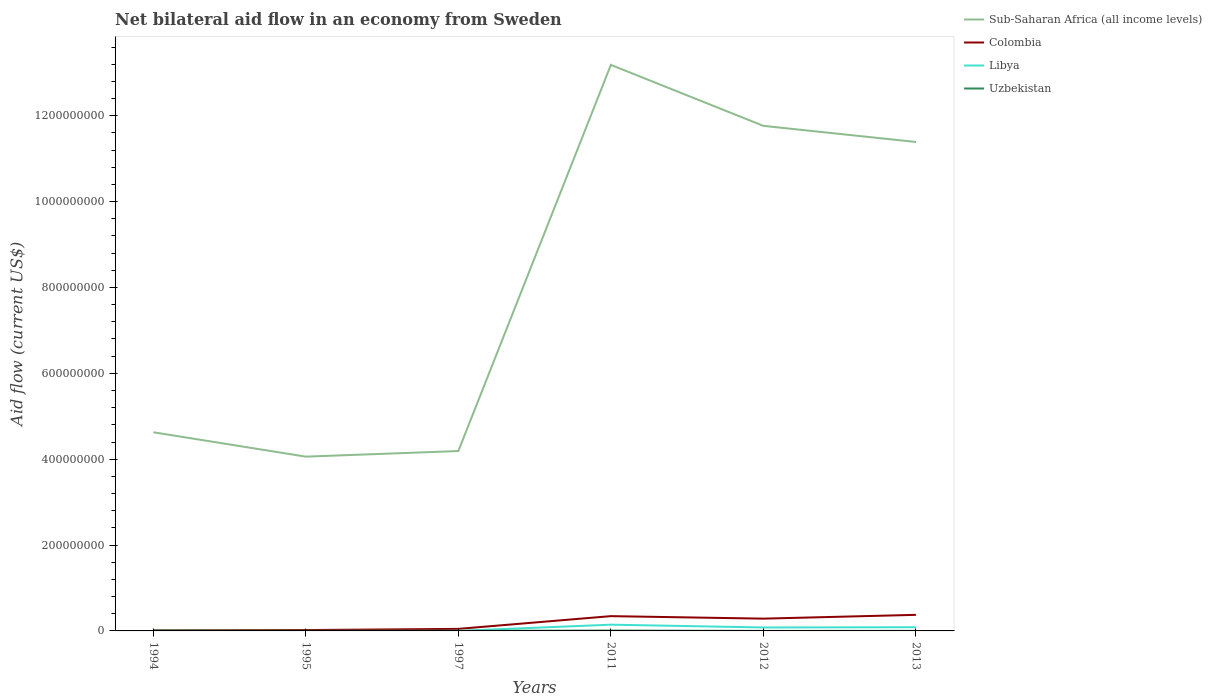Across all years, what is the maximum net bilateral aid flow in Sub-Saharan Africa (all income levels)?
Provide a succinct answer. 4.06e+08. In which year was the net bilateral aid flow in Libya maximum?
Provide a succinct answer. 1995. What is the total net bilateral aid flow in Uzbekistan in the graph?
Offer a very short reply. 8.10e+05. What is the difference between the highest and the second highest net bilateral aid flow in Colombia?
Keep it short and to the point. 3.62e+07. What is the difference between the highest and the lowest net bilateral aid flow in Uzbekistan?
Offer a terse response. 2. How many lines are there?
Your answer should be very brief. 4. What is the difference between two consecutive major ticks on the Y-axis?
Keep it short and to the point. 2.00e+08. Are the values on the major ticks of Y-axis written in scientific E-notation?
Ensure brevity in your answer.  No. Does the graph contain grids?
Give a very brief answer. No. Where does the legend appear in the graph?
Offer a terse response. Top right. How are the legend labels stacked?
Your answer should be very brief. Vertical. What is the title of the graph?
Provide a succinct answer. Net bilateral aid flow in an economy from Sweden. Does "Austria" appear as one of the legend labels in the graph?
Provide a succinct answer. No. What is the label or title of the X-axis?
Your response must be concise. Years. What is the Aid flow (current US$) in Sub-Saharan Africa (all income levels) in 1994?
Give a very brief answer. 4.63e+08. What is the Aid flow (current US$) in Colombia in 1994?
Ensure brevity in your answer.  1.24e+06. What is the Aid flow (current US$) of Libya in 1994?
Keep it short and to the point. 2.00e+04. What is the Aid flow (current US$) in Uzbekistan in 1994?
Offer a terse response. 8.60e+05. What is the Aid flow (current US$) in Sub-Saharan Africa (all income levels) in 1995?
Offer a very short reply. 4.06e+08. What is the Aid flow (current US$) in Colombia in 1995?
Offer a terse response. 2.02e+06. What is the Aid flow (current US$) in Libya in 1995?
Your answer should be compact. 10000. What is the Aid flow (current US$) of Sub-Saharan Africa (all income levels) in 1997?
Offer a very short reply. 4.19e+08. What is the Aid flow (current US$) of Colombia in 1997?
Your answer should be very brief. 4.76e+06. What is the Aid flow (current US$) in Sub-Saharan Africa (all income levels) in 2011?
Ensure brevity in your answer.  1.32e+09. What is the Aid flow (current US$) in Colombia in 2011?
Ensure brevity in your answer.  3.44e+07. What is the Aid flow (current US$) of Libya in 2011?
Ensure brevity in your answer.  1.46e+07. What is the Aid flow (current US$) of Uzbekistan in 2011?
Make the answer very short. 8.30e+05. What is the Aid flow (current US$) of Sub-Saharan Africa (all income levels) in 2012?
Offer a very short reply. 1.18e+09. What is the Aid flow (current US$) of Colombia in 2012?
Ensure brevity in your answer.  2.86e+07. What is the Aid flow (current US$) of Libya in 2012?
Your response must be concise. 8.03e+06. What is the Aid flow (current US$) in Uzbekistan in 2012?
Your answer should be very brief. 5.00e+04. What is the Aid flow (current US$) of Sub-Saharan Africa (all income levels) in 2013?
Ensure brevity in your answer.  1.14e+09. What is the Aid flow (current US$) of Colombia in 2013?
Provide a short and direct response. 3.74e+07. What is the Aid flow (current US$) of Libya in 2013?
Provide a succinct answer. 8.59e+06. Across all years, what is the maximum Aid flow (current US$) of Sub-Saharan Africa (all income levels)?
Your answer should be very brief. 1.32e+09. Across all years, what is the maximum Aid flow (current US$) of Colombia?
Provide a short and direct response. 3.74e+07. Across all years, what is the maximum Aid flow (current US$) of Libya?
Ensure brevity in your answer.  1.46e+07. Across all years, what is the maximum Aid flow (current US$) in Uzbekistan?
Provide a succinct answer. 8.60e+05. Across all years, what is the minimum Aid flow (current US$) of Sub-Saharan Africa (all income levels)?
Provide a short and direct response. 4.06e+08. Across all years, what is the minimum Aid flow (current US$) in Colombia?
Make the answer very short. 1.24e+06. What is the total Aid flow (current US$) of Sub-Saharan Africa (all income levels) in the graph?
Offer a terse response. 4.92e+09. What is the total Aid flow (current US$) in Colombia in the graph?
Your answer should be compact. 1.09e+08. What is the total Aid flow (current US$) of Libya in the graph?
Make the answer very short. 3.13e+07. What is the total Aid flow (current US$) in Uzbekistan in the graph?
Your response must be concise. 2.07e+06. What is the difference between the Aid flow (current US$) in Sub-Saharan Africa (all income levels) in 1994 and that in 1995?
Your answer should be compact. 5.68e+07. What is the difference between the Aid flow (current US$) of Colombia in 1994 and that in 1995?
Keep it short and to the point. -7.80e+05. What is the difference between the Aid flow (current US$) in Uzbekistan in 1994 and that in 1995?
Offer a very short reply. 7.20e+05. What is the difference between the Aid flow (current US$) of Sub-Saharan Africa (all income levels) in 1994 and that in 1997?
Your answer should be very brief. 4.37e+07. What is the difference between the Aid flow (current US$) in Colombia in 1994 and that in 1997?
Your response must be concise. -3.52e+06. What is the difference between the Aid flow (current US$) in Uzbekistan in 1994 and that in 1997?
Give a very brief answer. 7.30e+05. What is the difference between the Aid flow (current US$) of Sub-Saharan Africa (all income levels) in 1994 and that in 2011?
Keep it short and to the point. -8.56e+08. What is the difference between the Aid flow (current US$) in Colombia in 1994 and that in 2011?
Your answer should be very brief. -3.32e+07. What is the difference between the Aid flow (current US$) in Libya in 1994 and that in 2011?
Your response must be concise. -1.45e+07. What is the difference between the Aid flow (current US$) in Sub-Saharan Africa (all income levels) in 1994 and that in 2012?
Give a very brief answer. -7.14e+08. What is the difference between the Aid flow (current US$) in Colombia in 1994 and that in 2012?
Your response must be concise. -2.74e+07. What is the difference between the Aid flow (current US$) of Libya in 1994 and that in 2012?
Your response must be concise. -8.01e+06. What is the difference between the Aid flow (current US$) of Uzbekistan in 1994 and that in 2012?
Give a very brief answer. 8.10e+05. What is the difference between the Aid flow (current US$) in Sub-Saharan Africa (all income levels) in 1994 and that in 2013?
Your response must be concise. -6.76e+08. What is the difference between the Aid flow (current US$) of Colombia in 1994 and that in 2013?
Keep it short and to the point. -3.62e+07. What is the difference between the Aid flow (current US$) in Libya in 1994 and that in 2013?
Make the answer very short. -8.57e+06. What is the difference between the Aid flow (current US$) in Sub-Saharan Africa (all income levels) in 1995 and that in 1997?
Make the answer very short. -1.30e+07. What is the difference between the Aid flow (current US$) in Colombia in 1995 and that in 1997?
Your response must be concise. -2.74e+06. What is the difference between the Aid flow (current US$) of Sub-Saharan Africa (all income levels) in 1995 and that in 2011?
Your answer should be compact. -9.13e+08. What is the difference between the Aid flow (current US$) in Colombia in 1995 and that in 2011?
Keep it short and to the point. -3.24e+07. What is the difference between the Aid flow (current US$) of Libya in 1995 and that in 2011?
Make the answer very short. -1.46e+07. What is the difference between the Aid flow (current US$) of Uzbekistan in 1995 and that in 2011?
Keep it short and to the point. -6.90e+05. What is the difference between the Aid flow (current US$) of Sub-Saharan Africa (all income levels) in 1995 and that in 2012?
Provide a short and direct response. -7.70e+08. What is the difference between the Aid flow (current US$) in Colombia in 1995 and that in 2012?
Your answer should be very brief. -2.66e+07. What is the difference between the Aid flow (current US$) of Libya in 1995 and that in 2012?
Your answer should be compact. -8.02e+06. What is the difference between the Aid flow (current US$) of Uzbekistan in 1995 and that in 2012?
Provide a succinct answer. 9.00e+04. What is the difference between the Aid flow (current US$) in Sub-Saharan Africa (all income levels) in 1995 and that in 2013?
Your answer should be compact. -7.33e+08. What is the difference between the Aid flow (current US$) in Colombia in 1995 and that in 2013?
Offer a terse response. -3.54e+07. What is the difference between the Aid flow (current US$) of Libya in 1995 and that in 2013?
Provide a short and direct response. -8.58e+06. What is the difference between the Aid flow (current US$) of Uzbekistan in 1995 and that in 2013?
Your answer should be very brief. 8.00e+04. What is the difference between the Aid flow (current US$) in Sub-Saharan Africa (all income levels) in 1997 and that in 2011?
Offer a terse response. -9.00e+08. What is the difference between the Aid flow (current US$) in Colombia in 1997 and that in 2011?
Provide a succinct answer. -2.97e+07. What is the difference between the Aid flow (current US$) of Libya in 1997 and that in 2011?
Your answer should be very brief. -1.45e+07. What is the difference between the Aid flow (current US$) of Uzbekistan in 1997 and that in 2011?
Make the answer very short. -7.00e+05. What is the difference between the Aid flow (current US$) in Sub-Saharan Africa (all income levels) in 1997 and that in 2012?
Ensure brevity in your answer.  -7.57e+08. What is the difference between the Aid flow (current US$) of Colombia in 1997 and that in 2012?
Provide a short and direct response. -2.38e+07. What is the difference between the Aid flow (current US$) in Libya in 1997 and that in 2012?
Offer a very short reply. -7.93e+06. What is the difference between the Aid flow (current US$) in Sub-Saharan Africa (all income levels) in 1997 and that in 2013?
Offer a terse response. -7.20e+08. What is the difference between the Aid flow (current US$) of Colombia in 1997 and that in 2013?
Your answer should be very brief. -3.27e+07. What is the difference between the Aid flow (current US$) in Libya in 1997 and that in 2013?
Your response must be concise. -8.49e+06. What is the difference between the Aid flow (current US$) in Sub-Saharan Africa (all income levels) in 2011 and that in 2012?
Your answer should be very brief. 1.42e+08. What is the difference between the Aid flow (current US$) in Colombia in 2011 and that in 2012?
Give a very brief answer. 5.83e+06. What is the difference between the Aid flow (current US$) in Libya in 2011 and that in 2012?
Offer a terse response. 6.53e+06. What is the difference between the Aid flow (current US$) of Uzbekistan in 2011 and that in 2012?
Your answer should be compact. 7.80e+05. What is the difference between the Aid flow (current US$) of Sub-Saharan Africa (all income levels) in 2011 and that in 2013?
Make the answer very short. 1.80e+08. What is the difference between the Aid flow (current US$) of Colombia in 2011 and that in 2013?
Provide a short and direct response. -3.01e+06. What is the difference between the Aid flow (current US$) in Libya in 2011 and that in 2013?
Your answer should be compact. 5.97e+06. What is the difference between the Aid flow (current US$) of Uzbekistan in 2011 and that in 2013?
Ensure brevity in your answer.  7.70e+05. What is the difference between the Aid flow (current US$) of Sub-Saharan Africa (all income levels) in 2012 and that in 2013?
Provide a short and direct response. 3.76e+07. What is the difference between the Aid flow (current US$) of Colombia in 2012 and that in 2013?
Keep it short and to the point. -8.84e+06. What is the difference between the Aid flow (current US$) of Libya in 2012 and that in 2013?
Provide a short and direct response. -5.60e+05. What is the difference between the Aid flow (current US$) in Sub-Saharan Africa (all income levels) in 1994 and the Aid flow (current US$) in Colombia in 1995?
Keep it short and to the point. 4.61e+08. What is the difference between the Aid flow (current US$) in Sub-Saharan Africa (all income levels) in 1994 and the Aid flow (current US$) in Libya in 1995?
Ensure brevity in your answer.  4.63e+08. What is the difference between the Aid flow (current US$) in Sub-Saharan Africa (all income levels) in 1994 and the Aid flow (current US$) in Uzbekistan in 1995?
Give a very brief answer. 4.63e+08. What is the difference between the Aid flow (current US$) in Colombia in 1994 and the Aid flow (current US$) in Libya in 1995?
Offer a terse response. 1.23e+06. What is the difference between the Aid flow (current US$) of Colombia in 1994 and the Aid flow (current US$) of Uzbekistan in 1995?
Make the answer very short. 1.10e+06. What is the difference between the Aid flow (current US$) of Libya in 1994 and the Aid flow (current US$) of Uzbekistan in 1995?
Your answer should be very brief. -1.20e+05. What is the difference between the Aid flow (current US$) in Sub-Saharan Africa (all income levels) in 1994 and the Aid flow (current US$) in Colombia in 1997?
Ensure brevity in your answer.  4.58e+08. What is the difference between the Aid flow (current US$) of Sub-Saharan Africa (all income levels) in 1994 and the Aid flow (current US$) of Libya in 1997?
Offer a very short reply. 4.63e+08. What is the difference between the Aid flow (current US$) of Sub-Saharan Africa (all income levels) in 1994 and the Aid flow (current US$) of Uzbekistan in 1997?
Your response must be concise. 4.63e+08. What is the difference between the Aid flow (current US$) of Colombia in 1994 and the Aid flow (current US$) of Libya in 1997?
Provide a succinct answer. 1.14e+06. What is the difference between the Aid flow (current US$) of Colombia in 1994 and the Aid flow (current US$) of Uzbekistan in 1997?
Give a very brief answer. 1.11e+06. What is the difference between the Aid flow (current US$) in Sub-Saharan Africa (all income levels) in 1994 and the Aid flow (current US$) in Colombia in 2011?
Offer a terse response. 4.28e+08. What is the difference between the Aid flow (current US$) in Sub-Saharan Africa (all income levels) in 1994 and the Aid flow (current US$) in Libya in 2011?
Give a very brief answer. 4.48e+08. What is the difference between the Aid flow (current US$) in Sub-Saharan Africa (all income levels) in 1994 and the Aid flow (current US$) in Uzbekistan in 2011?
Your response must be concise. 4.62e+08. What is the difference between the Aid flow (current US$) in Colombia in 1994 and the Aid flow (current US$) in Libya in 2011?
Provide a succinct answer. -1.33e+07. What is the difference between the Aid flow (current US$) in Libya in 1994 and the Aid flow (current US$) in Uzbekistan in 2011?
Ensure brevity in your answer.  -8.10e+05. What is the difference between the Aid flow (current US$) in Sub-Saharan Africa (all income levels) in 1994 and the Aid flow (current US$) in Colombia in 2012?
Provide a short and direct response. 4.34e+08. What is the difference between the Aid flow (current US$) in Sub-Saharan Africa (all income levels) in 1994 and the Aid flow (current US$) in Libya in 2012?
Your answer should be very brief. 4.55e+08. What is the difference between the Aid flow (current US$) of Sub-Saharan Africa (all income levels) in 1994 and the Aid flow (current US$) of Uzbekistan in 2012?
Make the answer very short. 4.63e+08. What is the difference between the Aid flow (current US$) of Colombia in 1994 and the Aid flow (current US$) of Libya in 2012?
Give a very brief answer. -6.79e+06. What is the difference between the Aid flow (current US$) in Colombia in 1994 and the Aid flow (current US$) in Uzbekistan in 2012?
Your answer should be very brief. 1.19e+06. What is the difference between the Aid flow (current US$) in Libya in 1994 and the Aid flow (current US$) in Uzbekistan in 2012?
Offer a very short reply. -3.00e+04. What is the difference between the Aid flow (current US$) in Sub-Saharan Africa (all income levels) in 1994 and the Aid flow (current US$) in Colombia in 2013?
Your response must be concise. 4.25e+08. What is the difference between the Aid flow (current US$) in Sub-Saharan Africa (all income levels) in 1994 and the Aid flow (current US$) in Libya in 2013?
Offer a terse response. 4.54e+08. What is the difference between the Aid flow (current US$) in Sub-Saharan Africa (all income levels) in 1994 and the Aid flow (current US$) in Uzbekistan in 2013?
Offer a very short reply. 4.63e+08. What is the difference between the Aid flow (current US$) in Colombia in 1994 and the Aid flow (current US$) in Libya in 2013?
Offer a very short reply. -7.35e+06. What is the difference between the Aid flow (current US$) of Colombia in 1994 and the Aid flow (current US$) of Uzbekistan in 2013?
Keep it short and to the point. 1.18e+06. What is the difference between the Aid flow (current US$) in Libya in 1994 and the Aid flow (current US$) in Uzbekistan in 2013?
Offer a terse response. -4.00e+04. What is the difference between the Aid flow (current US$) in Sub-Saharan Africa (all income levels) in 1995 and the Aid flow (current US$) in Colombia in 1997?
Offer a very short reply. 4.01e+08. What is the difference between the Aid flow (current US$) in Sub-Saharan Africa (all income levels) in 1995 and the Aid flow (current US$) in Libya in 1997?
Ensure brevity in your answer.  4.06e+08. What is the difference between the Aid flow (current US$) of Sub-Saharan Africa (all income levels) in 1995 and the Aid flow (current US$) of Uzbekistan in 1997?
Your answer should be very brief. 4.06e+08. What is the difference between the Aid flow (current US$) of Colombia in 1995 and the Aid flow (current US$) of Libya in 1997?
Your answer should be very brief. 1.92e+06. What is the difference between the Aid flow (current US$) in Colombia in 1995 and the Aid flow (current US$) in Uzbekistan in 1997?
Make the answer very short. 1.89e+06. What is the difference between the Aid flow (current US$) of Sub-Saharan Africa (all income levels) in 1995 and the Aid flow (current US$) of Colombia in 2011?
Your answer should be very brief. 3.72e+08. What is the difference between the Aid flow (current US$) in Sub-Saharan Africa (all income levels) in 1995 and the Aid flow (current US$) in Libya in 2011?
Make the answer very short. 3.91e+08. What is the difference between the Aid flow (current US$) in Sub-Saharan Africa (all income levels) in 1995 and the Aid flow (current US$) in Uzbekistan in 2011?
Make the answer very short. 4.05e+08. What is the difference between the Aid flow (current US$) of Colombia in 1995 and the Aid flow (current US$) of Libya in 2011?
Give a very brief answer. -1.25e+07. What is the difference between the Aid flow (current US$) in Colombia in 1995 and the Aid flow (current US$) in Uzbekistan in 2011?
Give a very brief answer. 1.19e+06. What is the difference between the Aid flow (current US$) of Libya in 1995 and the Aid flow (current US$) of Uzbekistan in 2011?
Your response must be concise. -8.20e+05. What is the difference between the Aid flow (current US$) of Sub-Saharan Africa (all income levels) in 1995 and the Aid flow (current US$) of Colombia in 2012?
Provide a short and direct response. 3.77e+08. What is the difference between the Aid flow (current US$) of Sub-Saharan Africa (all income levels) in 1995 and the Aid flow (current US$) of Libya in 2012?
Offer a very short reply. 3.98e+08. What is the difference between the Aid flow (current US$) in Sub-Saharan Africa (all income levels) in 1995 and the Aid flow (current US$) in Uzbekistan in 2012?
Provide a succinct answer. 4.06e+08. What is the difference between the Aid flow (current US$) in Colombia in 1995 and the Aid flow (current US$) in Libya in 2012?
Provide a short and direct response. -6.01e+06. What is the difference between the Aid flow (current US$) in Colombia in 1995 and the Aid flow (current US$) in Uzbekistan in 2012?
Offer a very short reply. 1.97e+06. What is the difference between the Aid flow (current US$) in Libya in 1995 and the Aid flow (current US$) in Uzbekistan in 2012?
Your answer should be compact. -4.00e+04. What is the difference between the Aid flow (current US$) of Sub-Saharan Africa (all income levels) in 1995 and the Aid flow (current US$) of Colombia in 2013?
Offer a terse response. 3.69e+08. What is the difference between the Aid flow (current US$) in Sub-Saharan Africa (all income levels) in 1995 and the Aid flow (current US$) in Libya in 2013?
Offer a very short reply. 3.97e+08. What is the difference between the Aid flow (current US$) in Sub-Saharan Africa (all income levels) in 1995 and the Aid flow (current US$) in Uzbekistan in 2013?
Make the answer very short. 4.06e+08. What is the difference between the Aid flow (current US$) in Colombia in 1995 and the Aid flow (current US$) in Libya in 2013?
Your response must be concise. -6.57e+06. What is the difference between the Aid flow (current US$) of Colombia in 1995 and the Aid flow (current US$) of Uzbekistan in 2013?
Keep it short and to the point. 1.96e+06. What is the difference between the Aid flow (current US$) in Libya in 1995 and the Aid flow (current US$) in Uzbekistan in 2013?
Keep it short and to the point. -5.00e+04. What is the difference between the Aid flow (current US$) in Sub-Saharan Africa (all income levels) in 1997 and the Aid flow (current US$) in Colombia in 2011?
Your response must be concise. 3.85e+08. What is the difference between the Aid flow (current US$) of Sub-Saharan Africa (all income levels) in 1997 and the Aid flow (current US$) of Libya in 2011?
Provide a short and direct response. 4.04e+08. What is the difference between the Aid flow (current US$) of Sub-Saharan Africa (all income levels) in 1997 and the Aid flow (current US$) of Uzbekistan in 2011?
Provide a short and direct response. 4.18e+08. What is the difference between the Aid flow (current US$) in Colombia in 1997 and the Aid flow (current US$) in Libya in 2011?
Offer a very short reply. -9.80e+06. What is the difference between the Aid flow (current US$) of Colombia in 1997 and the Aid flow (current US$) of Uzbekistan in 2011?
Ensure brevity in your answer.  3.93e+06. What is the difference between the Aid flow (current US$) of Libya in 1997 and the Aid flow (current US$) of Uzbekistan in 2011?
Your answer should be very brief. -7.30e+05. What is the difference between the Aid flow (current US$) of Sub-Saharan Africa (all income levels) in 1997 and the Aid flow (current US$) of Colombia in 2012?
Provide a short and direct response. 3.90e+08. What is the difference between the Aid flow (current US$) of Sub-Saharan Africa (all income levels) in 1997 and the Aid flow (current US$) of Libya in 2012?
Offer a terse response. 4.11e+08. What is the difference between the Aid flow (current US$) of Sub-Saharan Africa (all income levels) in 1997 and the Aid flow (current US$) of Uzbekistan in 2012?
Your response must be concise. 4.19e+08. What is the difference between the Aid flow (current US$) of Colombia in 1997 and the Aid flow (current US$) of Libya in 2012?
Your response must be concise. -3.27e+06. What is the difference between the Aid flow (current US$) of Colombia in 1997 and the Aid flow (current US$) of Uzbekistan in 2012?
Your response must be concise. 4.71e+06. What is the difference between the Aid flow (current US$) of Sub-Saharan Africa (all income levels) in 1997 and the Aid flow (current US$) of Colombia in 2013?
Provide a short and direct response. 3.82e+08. What is the difference between the Aid flow (current US$) in Sub-Saharan Africa (all income levels) in 1997 and the Aid flow (current US$) in Libya in 2013?
Provide a short and direct response. 4.10e+08. What is the difference between the Aid flow (current US$) in Sub-Saharan Africa (all income levels) in 1997 and the Aid flow (current US$) in Uzbekistan in 2013?
Provide a short and direct response. 4.19e+08. What is the difference between the Aid flow (current US$) of Colombia in 1997 and the Aid flow (current US$) of Libya in 2013?
Provide a succinct answer. -3.83e+06. What is the difference between the Aid flow (current US$) in Colombia in 1997 and the Aid flow (current US$) in Uzbekistan in 2013?
Make the answer very short. 4.70e+06. What is the difference between the Aid flow (current US$) in Sub-Saharan Africa (all income levels) in 2011 and the Aid flow (current US$) in Colombia in 2012?
Give a very brief answer. 1.29e+09. What is the difference between the Aid flow (current US$) in Sub-Saharan Africa (all income levels) in 2011 and the Aid flow (current US$) in Libya in 2012?
Offer a very short reply. 1.31e+09. What is the difference between the Aid flow (current US$) of Sub-Saharan Africa (all income levels) in 2011 and the Aid flow (current US$) of Uzbekistan in 2012?
Offer a terse response. 1.32e+09. What is the difference between the Aid flow (current US$) in Colombia in 2011 and the Aid flow (current US$) in Libya in 2012?
Offer a very short reply. 2.64e+07. What is the difference between the Aid flow (current US$) in Colombia in 2011 and the Aid flow (current US$) in Uzbekistan in 2012?
Your response must be concise. 3.44e+07. What is the difference between the Aid flow (current US$) of Libya in 2011 and the Aid flow (current US$) of Uzbekistan in 2012?
Offer a terse response. 1.45e+07. What is the difference between the Aid flow (current US$) in Sub-Saharan Africa (all income levels) in 2011 and the Aid flow (current US$) in Colombia in 2013?
Your answer should be very brief. 1.28e+09. What is the difference between the Aid flow (current US$) of Sub-Saharan Africa (all income levels) in 2011 and the Aid flow (current US$) of Libya in 2013?
Ensure brevity in your answer.  1.31e+09. What is the difference between the Aid flow (current US$) in Sub-Saharan Africa (all income levels) in 2011 and the Aid flow (current US$) in Uzbekistan in 2013?
Ensure brevity in your answer.  1.32e+09. What is the difference between the Aid flow (current US$) of Colombia in 2011 and the Aid flow (current US$) of Libya in 2013?
Ensure brevity in your answer.  2.58e+07. What is the difference between the Aid flow (current US$) of Colombia in 2011 and the Aid flow (current US$) of Uzbekistan in 2013?
Provide a succinct answer. 3.44e+07. What is the difference between the Aid flow (current US$) in Libya in 2011 and the Aid flow (current US$) in Uzbekistan in 2013?
Your answer should be compact. 1.45e+07. What is the difference between the Aid flow (current US$) of Sub-Saharan Africa (all income levels) in 2012 and the Aid flow (current US$) of Colombia in 2013?
Your answer should be very brief. 1.14e+09. What is the difference between the Aid flow (current US$) of Sub-Saharan Africa (all income levels) in 2012 and the Aid flow (current US$) of Libya in 2013?
Offer a terse response. 1.17e+09. What is the difference between the Aid flow (current US$) of Sub-Saharan Africa (all income levels) in 2012 and the Aid flow (current US$) of Uzbekistan in 2013?
Offer a terse response. 1.18e+09. What is the difference between the Aid flow (current US$) of Colombia in 2012 and the Aid flow (current US$) of Libya in 2013?
Make the answer very short. 2.00e+07. What is the difference between the Aid flow (current US$) in Colombia in 2012 and the Aid flow (current US$) in Uzbekistan in 2013?
Ensure brevity in your answer.  2.86e+07. What is the difference between the Aid flow (current US$) in Libya in 2012 and the Aid flow (current US$) in Uzbekistan in 2013?
Make the answer very short. 7.97e+06. What is the average Aid flow (current US$) of Sub-Saharan Africa (all income levels) per year?
Your answer should be compact. 8.20e+08. What is the average Aid flow (current US$) of Colombia per year?
Offer a very short reply. 1.81e+07. What is the average Aid flow (current US$) in Libya per year?
Make the answer very short. 5.22e+06. What is the average Aid flow (current US$) of Uzbekistan per year?
Your response must be concise. 3.45e+05. In the year 1994, what is the difference between the Aid flow (current US$) in Sub-Saharan Africa (all income levels) and Aid flow (current US$) in Colombia?
Your answer should be very brief. 4.61e+08. In the year 1994, what is the difference between the Aid flow (current US$) in Sub-Saharan Africa (all income levels) and Aid flow (current US$) in Libya?
Offer a very short reply. 4.63e+08. In the year 1994, what is the difference between the Aid flow (current US$) of Sub-Saharan Africa (all income levels) and Aid flow (current US$) of Uzbekistan?
Your answer should be very brief. 4.62e+08. In the year 1994, what is the difference between the Aid flow (current US$) in Colombia and Aid flow (current US$) in Libya?
Make the answer very short. 1.22e+06. In the year 1994, what is the difference between the Aid flow (current US$) of Libya and Aid flow (current US$) of Uzbekistan?
Your response must be concise. -8.40e+05. In the year 1995, what is the difference between the Aid flow (current US$) in Sub-Saharan Africa (all income levels) and Aid flow (current US$) in Colombia?
Offer a terse response. 4.04e+08. In the year 1995, what is the difference between the Aid flow (current US$) in Sub-Saharan Africa (all income levels) and Aid flow (current US$) in Libya?
Your answer should be compact. 4.06e+08. In the year 1995, what is the difference between the Aid flow (current US$) in Sub-Saharan Africa (all income levels) and Aid flow (current US$) in Uzbekistan?
Offer a very short reply. 4.06e+08. In the year 1995, what is the difference between the Aid flow (current US$) in Colombia and Aid flow (current US$) in Libya?
Your answer should be very brief. 2.01e+06. In the year 1995, what is the difference between the Aid flow (current US$) in Colombia and Aid flow (current US$) in Uzbekistan?
Offer a terse response. 1.88e+06. In the year 1997, what is the difference between the Aid flow (current US$) in Sub-Saharan Africa (all income levels) and Aid flow (current US$) in Colombia?
Offer a terse response. 4.14e+08. In the year 1997, what is the difference between the Aid flow (current US$) of Sub-Saharan Africa (all income levels) and Aid flow (current US$) of Libya?
Offer a very short reply. 4.19e+08. In the year 1997, what is the difference between the Aid flow (current US$) in Sub-Saharan Africa (all income levels) and Aid flow (current US$) in Uzbekistan?
Offer a terse response. 4.19e+08. In the year 1997, what is the difference between the Aid flow (current US$) in Colombia and Aid flow (current US$) in Libya?
Offer a terse response. 4.66e+06. In the year 1997, what is the difference between the Aid flow (current US$) in Colombia and Aid flow (current US$) in Uzbekistan?
Offer a terse response. 4.63e+06. In the year 1997, what is the difference between the Aid flow (current US$) in Libya and Aid flow (current US$) in Uzbekistan?
Offer a very short reply. -3.00e+04. In the year 2011, what is the difference between the Aid flow (current US$) of Sub-Saharan Africa (all income levels) and Aid flow (current US$) of Colombia?
Your response must be concise. 1.28e+09. In the year 2011, what is the difference between the Aid flow (current US$) in Sub-Saharan Africa (all income levels) and Aid flow (current US$) in Libya?
Your answer should be very brief. 1.30e+09. In the year 2011, what is the difference between the Aid flow (current US$) in Sub-Saharan Africa (all income levels) and Aid flow (current US$) in Uzbekistan?
Make the answer very short. 1.32e+09. In the year 2011, what is the difference between the Aid flow (current US$) in Colombia and Aid flow (current US$) in Libya?
Ensure brevity in your answer.  1.99e+07. In the year 2011, what is the difference between the Aid flow (current US$) in Colombia and Aid flow (current US$) in Uzbekistan?
Offer a terse response. 3.36e+07. In the year 2011, what is the difference between the Aid flow (current US$) in Libya and Aid flow (current US$) in Uzbekistan?
Offer a terse response. 1.37e+07. In the year 2012, what is the difference between the Aid flow (current US$) in Sub-Saharan Africa (all income levels) and Aid flow (current US$) in Colombia?
Keep it short and to the point. 1.15e+09. In the year 2012, what is the difference between the Aid flow (current US$) in Sub-Saharan Africa (all income levels) and Aid flow (current US$) in Libya?
Your answer should be very brief. 1.17e+09. In the year 2012, what is the difference between the Aid flow (current US$) of Sub-Saharan Africa (all income levels) and Aid flow (current US$) of Uzbekistan?
Your response must be concise. 1.18e+09. In the year 2012, what is the difference between the Aid flow (current US$) of Colombia and Aid flow (current US$) of Libya?
Your response must be concise. 2.06e+07. In the year 2012, what is the difference between the Aid flow (current US$) of Colombia and Aid flow (current US$) of Uzbekistan?
Your answer should be very brief. 2.86e+07. In the year 2012, what is the difference between the Aid flow (current US$) in Libya and Aid flow (current US$) in Uzbekistan?
Your response must be concise. 7.98e+06. In the year 2013, what is the difference between the Aid flow (current US$) of Sub-Saharan Africa (all income levels) and Aid flow (current US$) of Colombia?
Your answer should be compact. 1.10e+09. In the year 2013, what is the difference between the Aid flow (current US$) in Sub-Saharan Africa (all income levels) and Aid flow (current US$) in Libya?
Your response must be concise. 1.13e+09. In the year 2013, what is the difference between the Aid flow (current US$) in Sub-Saharan Africa (all income levels) and Aid flow (current US$) in Uzbekistan?
Provide a succinct answer. 1.14e+09. In the year 2013, what is the difference between the Aid flow (current US$) of Colombia and Aid flow (current US$) of Libya?
Give a very brief answer. 2.89e+07. In the year 2013, what is the difference between the Aid flow (current US$) in Colombia and Aid flow (current US$) in Uzbekistan?
Give a very brief answer. 3.74e+07. In the year 2013, what is the difference between the Aid flow (current US$) in Libya and Aid flow (current US$) in Uzbekistan?
Make the answer very short. 8.53e+06. What is the ratio of the Aid flow (current US$) in Sub-Saharan Africa (all income levels) in 1994 to that in 1995?
Offer a terse response. 1.14. What is the ratio of the Aid flow (current US$) of Colombia in 1994 to that in 1995?
Your response must be concise. 0.61. What is the ratio of the Aid flow (current US$) in Libya in 1994 to that in 1995?
Give a very brief answer. 2. What is the ratio of the Aid flow (current US$) in Uzbekistan in 1994 to that in 1995?
Make the answer very short. 6.14. What is the ratio of the Aid flow (current US$) in Sub-Saharan Africa (all income levels) in 1994 to that in 1997?
Ensure brevity in your answer.  1.1. What is the ratio of the Aid flow (current US$) in Colombia in 1994 to that in 1997?
Your response must be concise. 0.26. What is the ratio of the Aid flow (current US$) in Libya in 1994 to that in 1997?
Provide a short and direct response. 0.2. What is the ratio of the Aid flow (current US$) of Uzbekistan in 1994 to that in 1997?
Offer a terse response. 6.62. What is the ratio of the Aid flow (current US$) in Sub-Saharan Africa (all income levels) in 1994 to that in 2011?
Your response must be concise. 0.35. What is the ratio of the Aid flow (current US$) in Colombia in 1994 to that in 2011?
Your response must be concise. 0.04. What is the ratio of the Aid flow (current US$) in Libya in 1994 to that in 2011?
Provide a succinct answer. 0. What is the ratio of the Aid flow (current US$) in Uzbekistan in 1994 to that in 2011?
Your answer should be compact. 1.04. What is the ratio of the Aid flow (current US$) in Sub-Saharan Africa (all income levels) in 1994 to that in 2012?
Keep it short and to the point. 0.39. What is the ratio of the Aid flow (current US$) of Colombia in 1994 to that in 2012?
Offer a very short reply. 0.04. What is the ratio of the Aid flow (current US$) in Libya in 1994 to that in 2012?
Make the answer very short. 0. What is the ratio of the Aid flow (current US$) of Sub-Saharan Africa (all income levels) in 1994 to that in 2013?
Give a very brief answer. 0.41. What is the ratio of the Aid flow (current US$) in Colombia in 1994 to that in 2013?
Provide a short and direct response. 0.03. What is the ratio of the Aid flow (current US$) in Libya in 1994 to that in 2013?
Your answer should be very brief. 0. What is the ratio of the Aid flow (current US$) in Uzbekistan in 1994 to that in 2013?
Offer a very short reply. 14.33. What is the ratio of the Aid flow (current US$) in Sub-Saharan Africa (all income levels) in 1995 to that in 1997?
Give a very brief answer. 0.97. What is the ratio of the Aid flow (current US$) in Colombia in 1995 to that in 1997?
Ensure brevity in your answer.  0.42. What is the ratio of the Aid flow (current US$) of Sub-Saharan Africa (all income levels) in 1995 to that in 2011?
Give a very brief answer. 0.31. What is the ratio of the Aid flow (current US$) of Colombia in 1995 to that in 2011?
Your answer should be compact. 0.06. What is the ratio of the Aid flow (current US$) of Libya in 1995 to that in 2011?
Offer a terse response. 0. What is the ratio of the Aid flow (current US$) of Uzbekistan in 1995 to that in 2011?
Provide a short and direct response. 0.17. What is the ratio of the Aid flow (current US$) of Sub-Saharan Africa (all income levels) in 1995 to that in 2012?
Your answer should be compact. 0.35. What is the ratio of the Aid flow (current US$) in Colombia in 1995 to that in 2012?
Ensure brevity in your answer.  0.07. What is the ratio of the Aid flow (current US$) of Libya in 1995 to that in 2012?
Provide a succinct answer. 0. What is the ratio of the Aid flow (current US$) of Sub-Saharan Africa (all income levels) in 1995 to that in 2013?
Provide a short and direct response. 0.36. What is the ratio of the Aid flow (current US$) in Colombia in 1995 to that in 2013?
Your response must be concise. 0.05. What is the ratio of the Aid flow (current US$) in Libya in 1995 to that in 2013?
Keep it short and to the point. 0. What is the ratio of the Aid flow (current US$) in Uzbekistan in 1995 to that in 2013?
Make the answer very short. 2.33. What is the ratio of the Aid flow (current US$) of Sub-Saharan Africa (all income levels) in 1997 to that in 2011?
Provide a short and direct response. 0.32. What is the ratio of the Aid flow (current US$) of Colombia in 1997 to that in 2011?
Provide a succinct answer. 0.14. What is the ratio of the Aid flow (current US$) of Libya in 1997 to that in 2011?
Keep it short and to the point. 0.01. What is the ratio of the Aid flow (current US$) of Uzbekistan in 1997 to that in 2011?
Offer a terse response. 0.16. What is the ratio of the Aid flow (current US$) of Sub-Saharan Africa (all income levels) in 1997 to that in 2012?
Your answer should be compact. 0.36. What is the ratio of the Aid flow (current US$) in Colombia in 1997 to that in 2012?
Offer a terse response. 0.17. What is the ratio of the Aid flow (current US$) of Libya in 1997 to that in 2012?
Make the answer very short. 0.01. What is the ratio of the Aid flow (current US$) of Uzbekistan in 1997 to that in 2012?
Your answer should be compact. 2.6. What is the ratio of the Aid flow (current US$) in Sub-Saharan Africa (all income levels) in 1997 to that in 2013?
Offer a terse response. 0.37. What is the ratio of the Aid flow (current US$) of Colombia in 1997 to that in 2013?
Make the answer very short. 0.13. What is the ratio of the Aid flow (current US$) of Libya in 1997 to that in 2013?
Make the answer very short. 0.01. What is the ratio of the Aid flow (current US$) of Uzbekistan in 1997 to that in 2013?
Make the answer very short. 2.17. What is the ratio of the Aid flow (current US$) in Sub-Saharan Africa (all income levels) in 2011 to that in 2012?
Provide a short and direct response. 1.12. What is the ratio of the Aid flow (current US$) of Colombia in 2011 to that in 2012?
Your answer should be very brief. 1.2. What is the ratio of the Aid flow (current US$) of Libya in 2011 to that in 2012?
Offer a terse response. 1.81. What is the ratio of the Aid flow (current US$) in Sub-Saharan Africa (all income levels) in 2011 to that in 2013?
Make the answer very short. 1.16. What is the ratio of the Aid flow (current US$) of Colombia in 2011 to that in 2013?
Offer a terse response. 0.92. What is the ratio of the Aid flow (current US$) in Libya in 2011 to that in 2013?
Your answer should be very brief. 1.7. What is the ratio of the Aid flow (current US$) of Uzbekistan in 2011 to that in 2013?
Offer a very short reply. 13.83. What is the ratio of the Aid flow (current US$) in Sub-Saharan Africa (all income levels) in 2012 to that in 2013?
Offer a terse response. 1.03. What is the ratio of the Aid flow (current US$) in Colombia in 2012 to that in 2013?
Your answer should be very brief. 0.76. What is the ratio of the Aid flow (current US$) of Libya in 2012 to that in 2013?
Offer a very short reply. 0.93. What is the difference between the highest and the second highest Aid flow (current US$) in Sub-Saharan Africa (all income levels)?
Offer a terse response. 1.42e+08. What is the difference between the highest and the second highest Aid flow (current US$) of Colombia?
Make the answer very short. 3.01e+06. What is the difference between the highest and the second highest Aid flow (current US$) in Libya?
Ensure brevity in your answer.  5.97e+06. What is the difference between the highest and the lowest Aid flow (current US$) of Sub-Saharan Africa (all income levels)?
Keep it short and to the point. 9.13e+08. What is the difference between the highest and the lowest Aid flow (current US$) in Colombia?
Your response must be concise. 3.62e+07. What is the difference between the highest and the lowest Aid flow (current US$) of Libya?
Your response must be concise. 1.46e+07. What is the difference between the highest and the lowest Aid flow (current US$) of Uzbekistan?
Provide a succinct answer. 8.10e+05. 